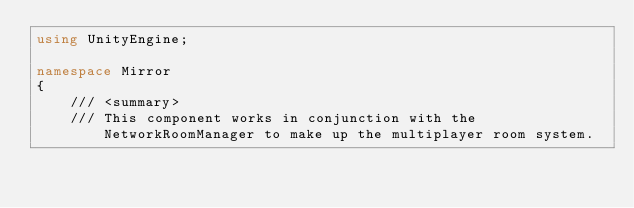Convert code to text. <code><loc_0><loc_0><loc_500><loc_500><_C#_>using UnityEngine;

namespace Mirror
{
    /// <summary>
    /// This component works in conjunction with the NetworkRoomManager to make up the multiplayer room system.</code> 